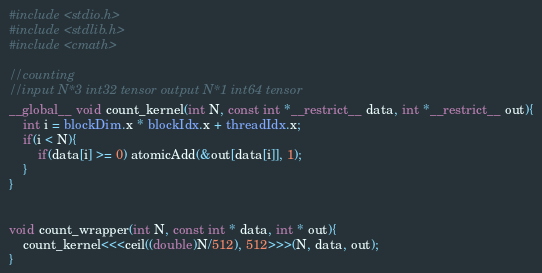Convert code to text. <code><loc_0><loc_0><loc_500><loc_500><_Cuda_>#include <stdio.h>
#include <stdlib.h>
#include <cmath>

//counting
//input N*3 int32 tensor output N*1 int64 tensor
__global__ void count_kernel(int N, const int *__restrict__ data, int *__restrict__ out){
    int i = blockDim.x * blockIdx.x + threadIdx.x;
    if(i < N){
        if(data[i] >= 0) atomicAdd(&out[data[i]], 1);
    }
}


void count_wrapper(int N, const int * data, int * out){
    count_kernel<<<ceil((double)N/512), 512>>>(N, data, out);
}
</code> 